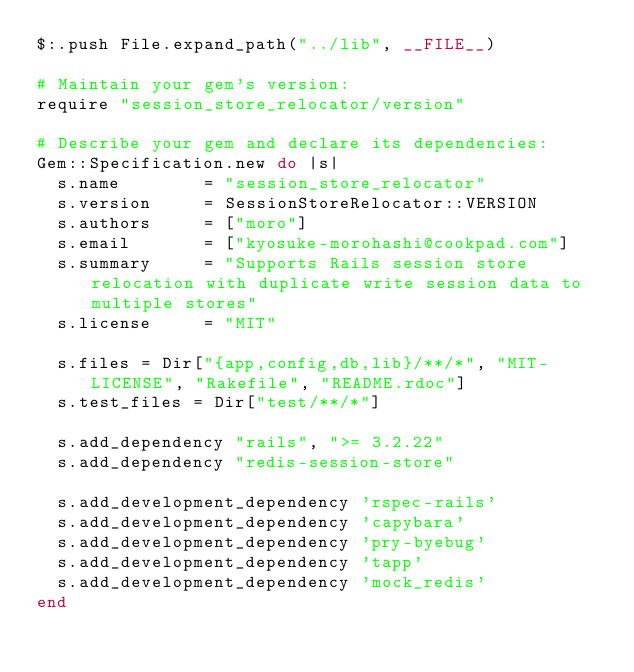<code> <loc_0><loc_0><loc_500><loc_500><_Ruby_>$:.push File.expand_path("../lib", __FILE__)

# Maintain your gem's version:
require "session_store_relocator/version"

# Describe your gem and declare its dependencies:
Gem::Specification.new do |s|
  s.name        = "session_store_relocator"
  s.version     = SessionStoreRelocator::VERSION
  s.authors     = ["moro"]
  s.email       = ["kyosuke-morohashi@cookpad.com"]
  s.summary     = "Supports Rails session store relocation with duplicate write session data to multiple stores"
  s.license     = "MIT"

  s.files = Dir["{app,config,db,lib}/**/*", "MIT-LICENSE", "Rakefile", "README.rdoc"]
  s.test_files = Dir["test/**/*"]

  s.add_dependency "rails", ">= 3.2.22"
  s.add_dependency "redis-session-store"

  s.add_development_dependency 'rspec-rails'
  s.add_development_dependency 'capybara'
  s.add_development_dependency 'pry-byebug'
  s.add_development_dependency 'tapp'
  s.add_development_dependency 'mock_redis'
end
</code> 